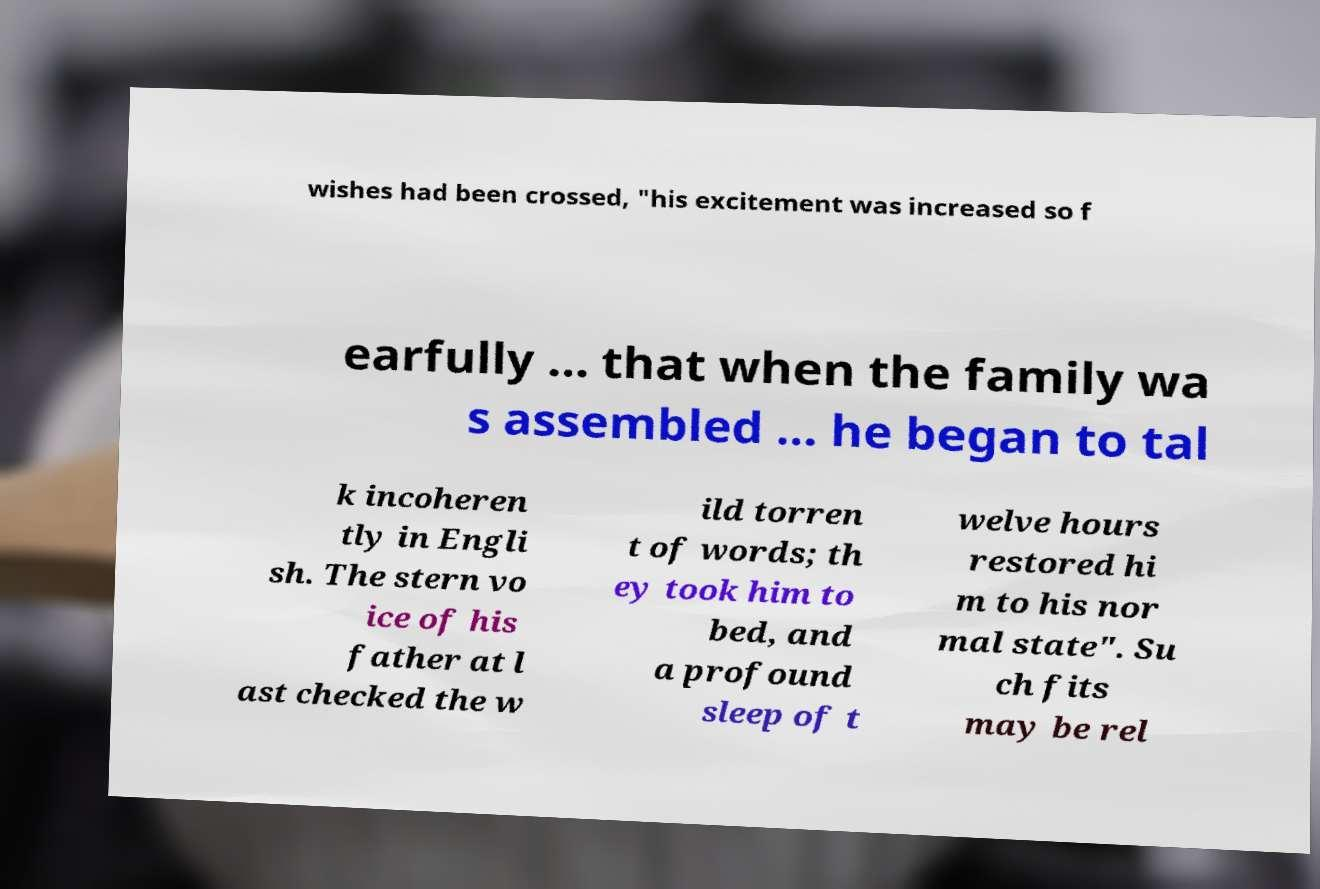Can you accurately transcribe the text from the provided image for me? wishes had been crossed, "his excitement was increased so f earfully ... that when the family wa s assembled ... he began to tal k incoheren tly in Engli sh. The stern vo ice of his father at l ast checked the w ild torren t of words; th ey took him to bed, and a profound sleep of t welve hours restored hi m to his nor mal state". Su ch fits may be rel 